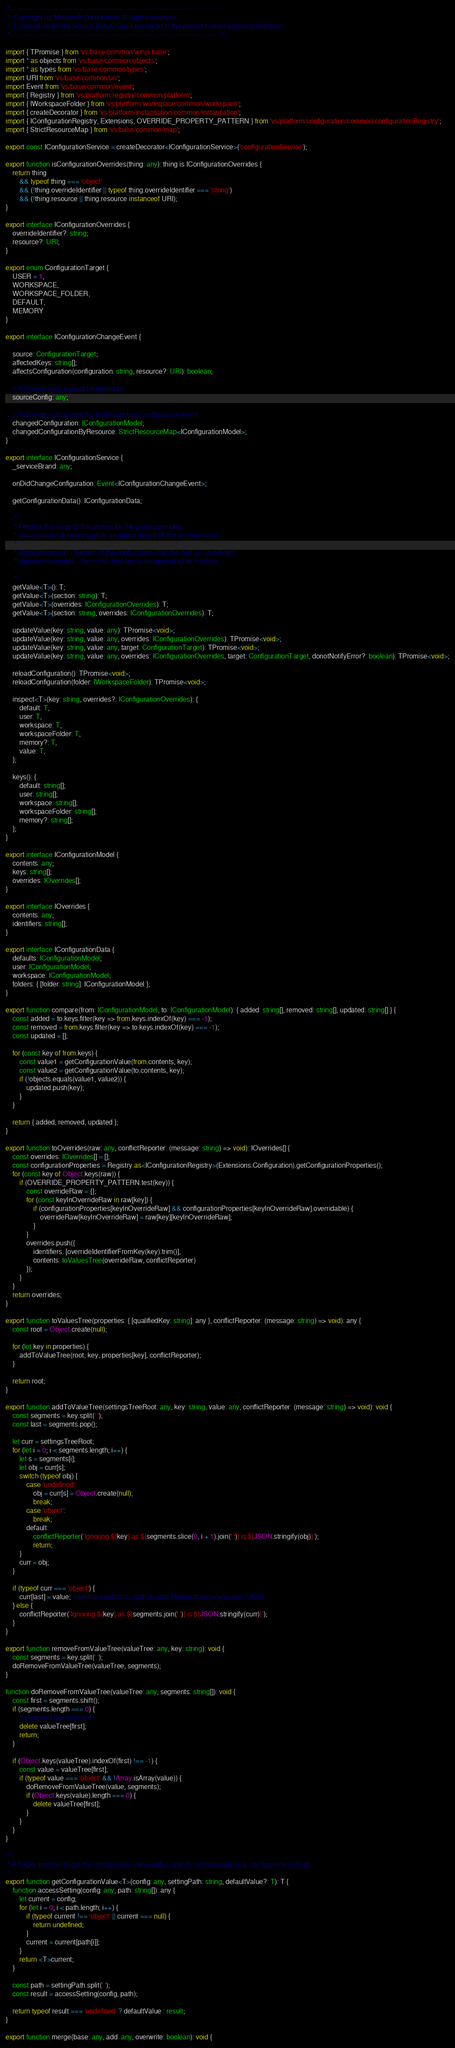Convert code to text. <code><loc_0><loc_0><loc_500><loc_500><_TypeScript_>/*---------------------------------------------------------------------------------------------
 *  Copyright (c) Microsoft Corporation. All rights reserved.
 *  Licensed under the Source EULA. See License.txt in the project root for license information.
 *--------------------------------------------------------------------------------------------*/

import { TPromise } from 'vs/base/common/winjs.base';
import * as objects from 'vs/base/common/objects';
import * as types from 'vs/base/common/types';
import URI from 'vs/base/common/uri';
import Event from 'vs/base/common/event';
import { Registry } from 'vs/platform/registry/common/platform';
import { IWorkspaceFolder } from 'vs/platform/workspace/common/workspace';
import { createDecorator } from 'vs/platform/instantiation/common/instantiation';
import { IConfigurationRegistry, Extensions, OVERRIDE_PROPERTY_PATTERN } from 'vs/platform/configuration/common/configurationRegistry';
import { StrictResourceMap } from 'vs/base/common/map';

export const IConfigurationService = createDecorator<IConfigurationService>('configurationService');

export function isConfigurationOverrides(thing: any): thing is IConfigurationOverrides {
	return thing
		&& typeof thing === 'object'
		&& (!thing.overrideIdentifier || typeof thing.overrideIdentifier === 'string')
		&& (!thing.resource || thing.resource instanceof URI);
}

export interface IConfigurationOverrides {
	overrideIdentifier?: string;
	resource?: URI;
}

export enum ConfigurationTarget {
	USER = 1,
	WORKSPACE,
	WORKSPACE_FOLDER,
	DEFAULT,
	MEMORY
}

export interface IConfigurationChangeEvent {

	source: ConfigurationTarget;
	affectedKeys: string[];
	affectsConfiguration(configuration: string, resource?: URI): boolean;

	// Following data is used for telemetry
	sourceConfig: any;

	// Following data is used for Extension host configuration event
	changedConfiguration: IConfigurationModel;
	changedConfigurationByResource: StrictResourceMap<IConfigurationModel>;
}

export interface IConfigurationService {
	_serviceBrand: any;

	onDidChangeConfiguration: Event<IConfigurationChangeEvent>;

	getConfigurationData(): IConfigurationData;

	/**
	 * Fetches the value of the section for the given overrides.
	 * Value can be of native type or an object keyed off the section name.
	 *
	 * @param section - Section of the configuraion. Can be `null` or `undefined`.
	 * @param overrides - Overrides that has to be applied while fetching
	 *
	 */
	getValue<T>(): T;
	getValue<T>(section: string): T;
	getValue<T>(overrides: IConfigurationOverrides): T;
	getValue<T>(section: string, overrides: IConfigurationOverrides): T;

	updateValue(key: string, value: any): TPromise<void>;
	updateValue(key: string, value: any, overrides: IConfigurationOverrides): TPromise<void>;
	updateValue(key: string, value: any, target: ConfigurationTarget): TPromise<void>;
	updateValue(key: string, value: any, overrides: IConfigurationOverrides, target: ConfigurationTarget, donotNotifyError?: boolean): TPromise<void>;

	reloadConfiguration(): TPromise<void>;
	reloadConfiguration(folder: IWorkspaceFolder): TPromise<void>;

	inspect<T>(key: string, overrides?: IConfigurationOverrides): {
		default: T,
		user: T,
		workspace: T,
		workspaceFolder: T,
		memory?: T,
		value: T,
	};

	keys(): {
		default: string[];
		user: string[];
		workspace: string[];
		workspaceFolder: string[];
		memory?: string[];
	};
}

export interface IConfigurationModel {
	contents: any;
	keys: string[];
	overrides: IOverrides[];
}

export interface IOverrides {
	contents: any;
	identifiers: string[];
}

export interface IConfigurationData {
	defaults: IConfigurationModel;
	user: IConfigurationModel;
	workspace: IConfigurationModel;
	folders: { [folder: string]: IConfigurationModel };
}

export function compare(from: IConfigurationModel, to: IConfigurationModel): { added: string[], removed: string[], updated: string[] } {
	const added = to.keys.filter(key => from.keys.indexOf(key) === -1);
	const removed = from.keys.filter(key => to.keys.indexOf(key) === -1);
	const updated = [];

	for (const key of from.keys) {
		const value1 = getConfigurationValue(from.contents, key);
		const value2 = getConfigurationValue(to.contents, key);
		if (!objects.equals(value1, value2)) {
			updated.push(key);
		}
	}

	return { added, removed, updated };
}

export function toOverrides(raw: any, conflictReporter: (message: string) => void): IOverrides[] {
	const overrides: IOverrides[] = [];
	const configurationProperties = Registry.as<IConfigurationRegistry>(Extensions.Configuration).getConfigurationProperties();
	for (const key of Object.keys(raw)) {
		if (OVERRIDE_PROPERTY_PATTERN.test(key)) {
			const overrideRaw = {};
			for (const keyInOverrideRaw in raw[key]) {
				if (configurationProperties[keyInOverrideRaw] && configurationProperties[keyInOverrideRaw].overridable) {
					overrideRaw[keyInOverrideRaw] = raw[key][keyInOverrideRaw];
				}
			}
			overrides.push({
				identifiers: [overrideIdentifierFromKey(key).trim()],
				contents: toValuesTree(overrideRaw, conflictReporter)
			});
		}
	}
	return overrides;
}

export function toValuesTree(properties: { [qualifiedKey: string]: any }, conflictReporter: (message: string) => void): any {
	const root = Object.create(null);

	for (let key in properties) {
		addToValueTree(root, key, properties[key], conflictReporter);
	}

	return root;
}

export function addToValueTree(settingsTreeRoot: any, key: string, value: any, conflictReporter: (message: string) => void): void {
	const segments = key.split('.');
	const last = segments.pop();

	let curr = settingsTreeRoot;
	for (let i = 0; i < segments.length; i++) {
		let s = segments[i];
		let obj = curr[s];
		switch (typeof obj) {
			case 'undefined':
				obj = curr[s] = Object.create(null);
				break;
			case 'object':
				break;
			default:
				conflictReporter(`Ignoring ${key} as ${segments.slice(0, i + 1).join('.')} is ${JSON.stringify(obj)}`);
				return;
		}
		curr = obj;
	}

	if (typeof curr === 'object') {
		curr[last] = value; // workaround https://github.com/Microsoft/vscode/issues/13606
	} else {
		conflictReporter(`Ignoring ${key} as ${segments.join('.')} is ${JSON.stringify(curr)}`);
	}
}

export function removeFromValueTree(valueTree: any, key: string): void {
	const segments = key.split('.');
	doRemoveFromValueTree(valueTree, segments);
}

function doRemoveFromValueTree(valueTree: any, segments: string[]): void {
	const first = segments.shift();
	if (segments.length === 0) {
		// Reached last segment
		delete valueTree[first];
		return;
	}

	if (Object.keys(valueTree).indexOf(first) !== -1) {
		const value = valueTree[first];
		if (typeof value === 'object' && !Array.isArray(value)) {
			doRemoveFromValueTree(value, segments);
			if (Object.keys(value).length === 0) {
				delete valueTree[first];
			}
		}
	}
}

/**
 * A helper function to get the configuration value with a specific settings path (e.g. config.some.setting)
 */
export function getConfigurationValue<T>(config: any, settingPath: string, defaultValue?: T): T {
	function accessSetting(config: any, path: string[]): any {
		let current = config;
		for (let i = 0; i < path.length; i++) {
			if (typeof current !== 'object' || current === null) {
				return undefined;
			}
			current = current[path[i]];
		}
		return <T>current;
	}

	const path = settingPath.split('.');
	const result = accessSetting(config, path);

	return typeof result === 'undefined' ? defaultValue : result;
}

export function merge(base: any, add: any, overwrite: boolean): void {</code> 